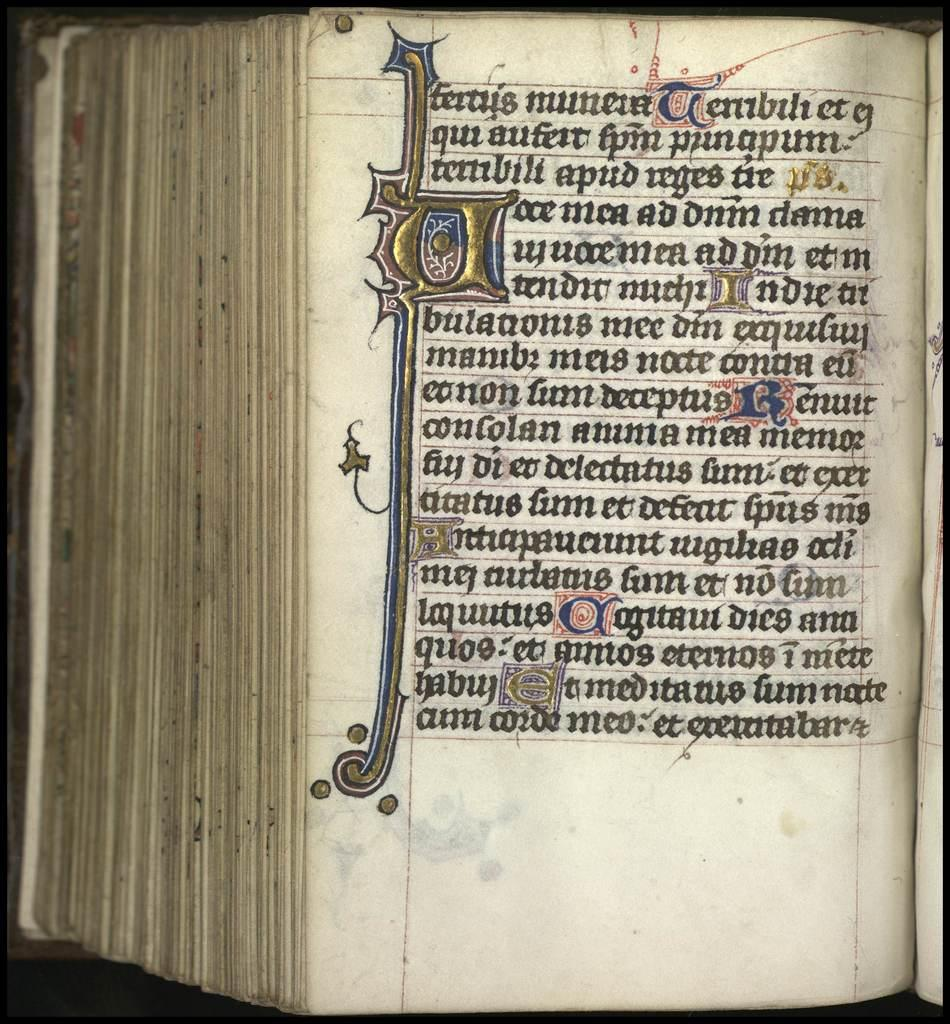<image>
Present a compact description of the photo's key features. Open book that starts off with "Tertris Munera". 